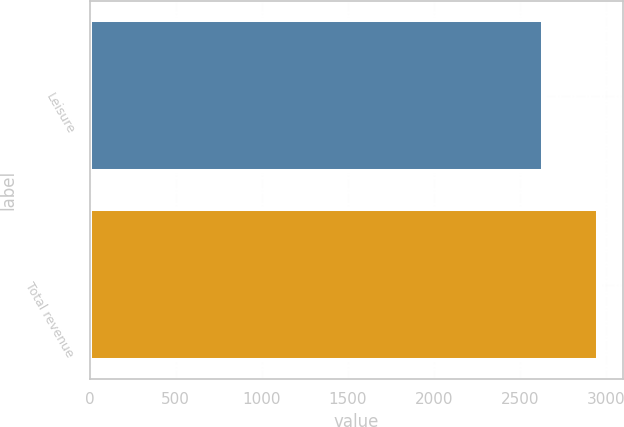Convert chart to OTSL. <chart><loc_0><loc_0><loc_500><loc_500><bar_chart><fcel>Leisure<fcel>Total revenue<nl><fcel>2635<fcel>2955<nl></chart> 